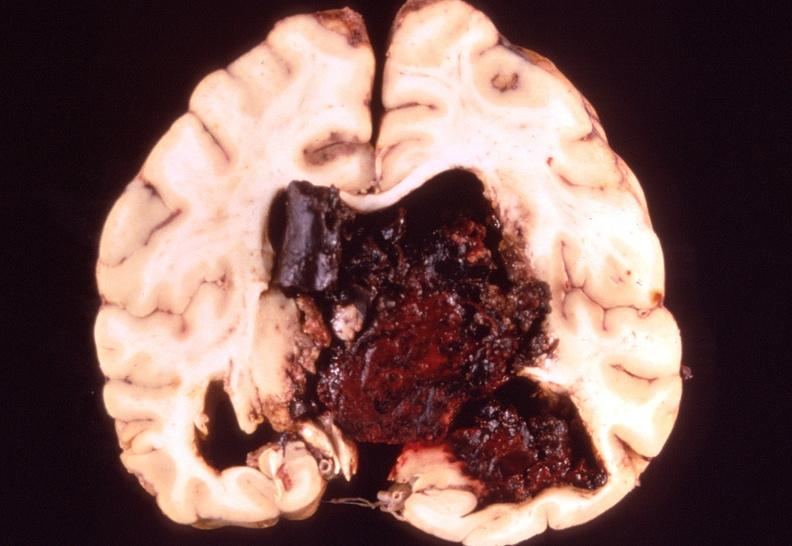what is present?
Answer the question using a single word or phrase. Nervous 